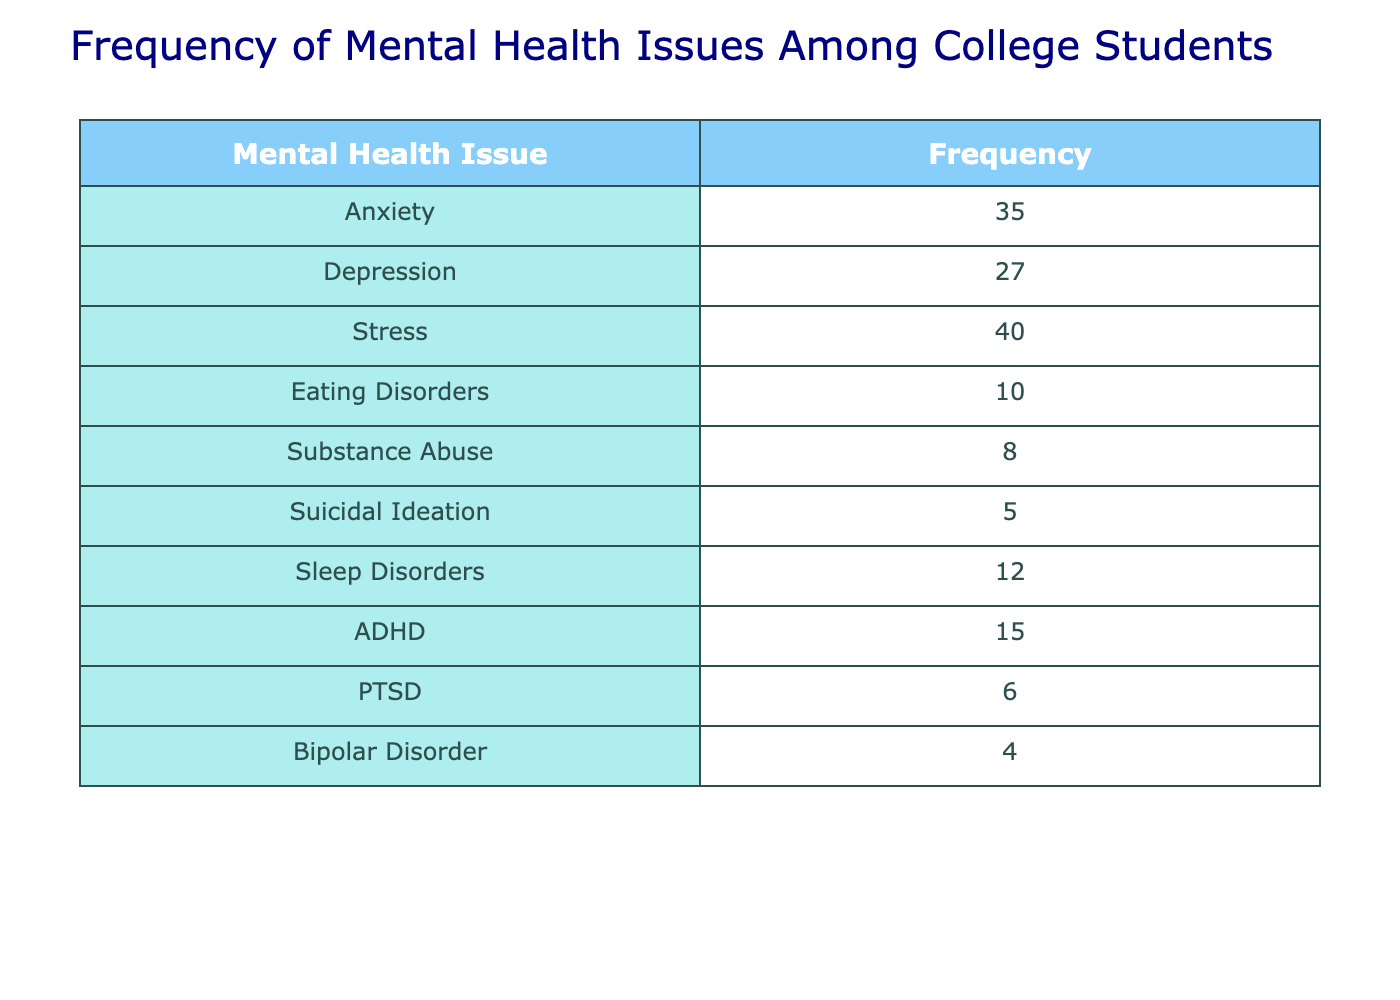What is the most frequently reported mental health issue among college students? The table shows the number of reported cases for each mental health issue. By comparing the frequencies, we see that "Stress" has the highest frequency at 40.
Answer: Stress How many students reported issues related to Anxiety? The table indicates that 35 students reported having Anxiety.
Answer: 35 What is the total frequency of Eating Disorders and Substance Abuse issues combined? To find the total, we add the frequencies of Eating Disorders (10) and Substance Abuse (8), which gives us 10 + 8 = 18.
Answer: 18 Is the frequency of Suicidal Ideation greater than that of Bipolar Disorder? Looking at the table, we see Suicidal Ideation has a frequency of 5, while Bipolar Disorder has a frequency of 4. Since 5 is greater than 4, the statement is true.
Answer: Yes What percentage of reported mental health issues corresponds to ADHD? The total frequencies sum up to 147 (35 + 27 + 40 + 10 + 8 + 5 + 12 + 15 + 6 + 4 = 147). The frequency of ADHD is 15. To find the percentage: (15 / 147) * 100 = approximately 10.2%.
Answer: 10.2% What is the difference in frequency between the highest and lowest reported mental health issues? The highest frequency is 40 (Stress) and the lowest is 4 (Bipolar Disorder). The difference is 40 - 4 = 36.
Answer: 36 How many students reported a frequency of mental health issues less than 10? By examining the table, we see that only Substance Abuse (8) and Bipolar Disorder (4) have frequencies less than 10. Thus, there are 2 reported issues.
Answer: 2 Which mental health issues have a frequency greater than or equal to 15? The mental health issues with a frequency of 15 or more are Anxiety (35), Stress (40), ADHD (15), and Depression (27). There are four issues in total.
Answer: 4 Is the frequency of Sleep Disorders equal to that of PTSD? The table shows Sleep Disorders with a frequency of 12 and PTSD with a frequency of 6. Therefore, the frequencies are not equal.
Answer: No 